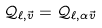Convert formula to latex. <formula><loc_0><loc_0><loc_500><loc_500>\mathcal { Q } _ { \ell , \vec { v } } = \mathcal { Q } _ { \ell , \alpha \vec { v } }</formula> 